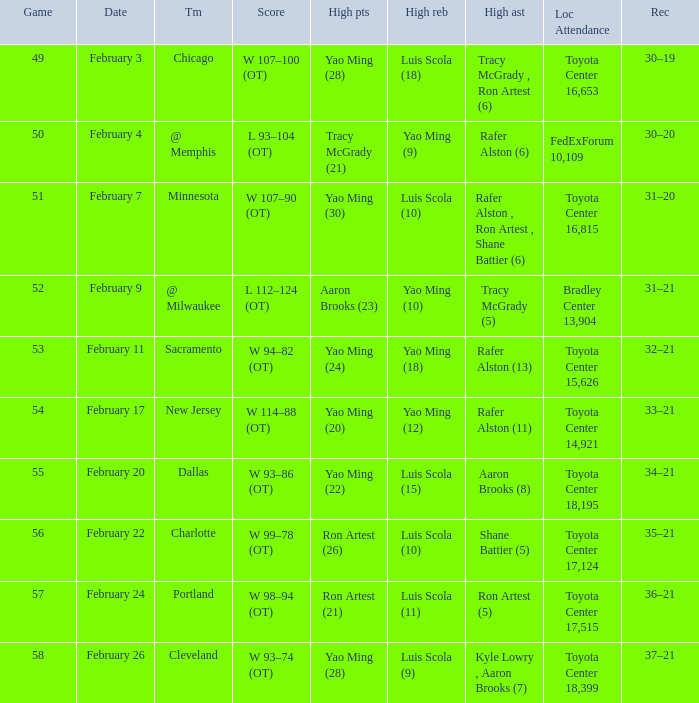Name the record for score of  l 93–104 (ot) 30–20. 